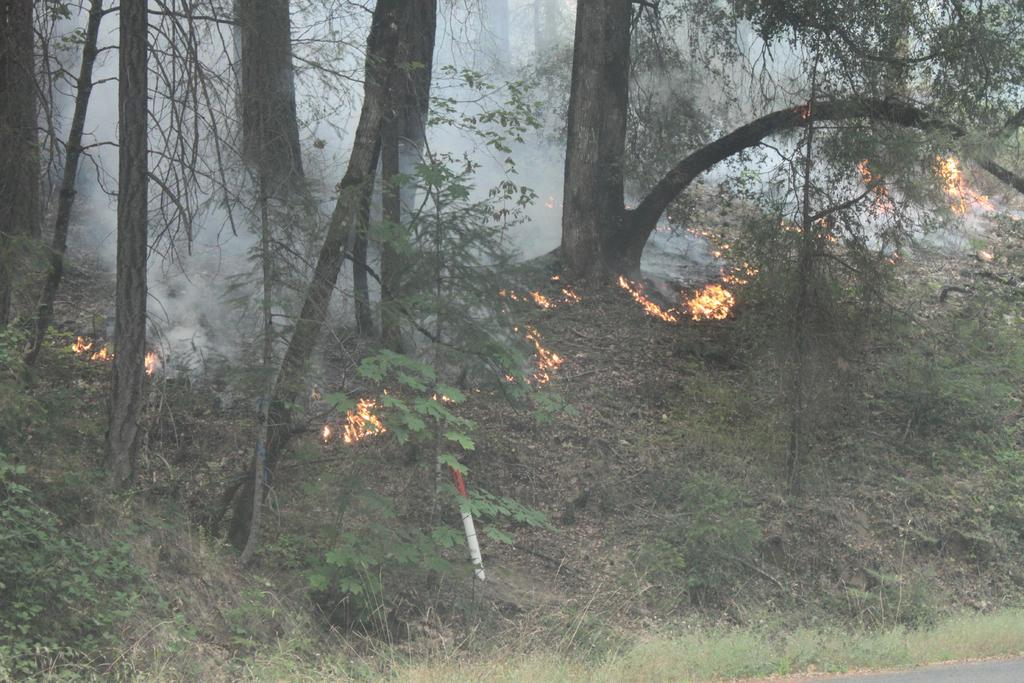What type of vegetation can be seen in the image? There is grass, plants, and trees in the image. What is the source of the smoke in the image? The source of the smoke is the fire in the image. Can you describe the natural environment depicted in the image? The image may have been taken in a forest, as it contains trees and other vegetation. What time of day might the image have been taken? The image may have been taken during the day, as there is sufficient light to see the details clearly. Can you see any cables hanging from the trees in the image? A: There are no cables visible in the image; it only contains grass, plants, trees, smoke, and fire. Is the father of the person who took the image present in the image? There is no indication of any people, including a father, in the image. 